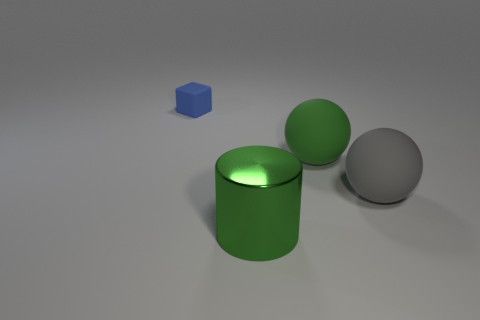Add 4 small blue metallic objects. How many objects exist? 8 Subtract all cylinders. How many objects are left? 3 Subtract all big green rubber objects. Subtract all green balls. How many objects are left? 2 Add 3 tiny blue objects. How many tiny blue objects are left? 4 Add 1 big green metal things. How many big green metal things exist? 2 Subtract 0 yellow cubes. How many objects are left? 4 